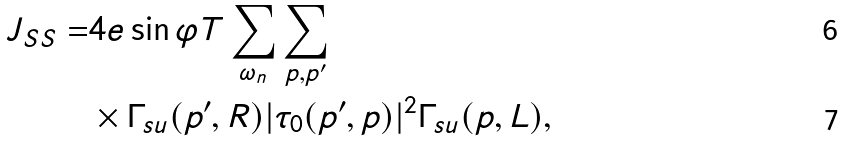Convert formula to latex. <formula><loc_0><loc_0><loc_500><loc_500>J _ { S S } = & 4 e \sin \varphi T \sum _ { \omega _ { n } } \sum _ { p , p ^ { \prime } } \\ & \times \Gamma _ { s u } ( p ^ { \prime } , R ) | \tau _ { 0 } ( p ^ { \prime } , p ) | ^ { 2 } \Gamma _ { s u } ( p , L ) ,</formula> 